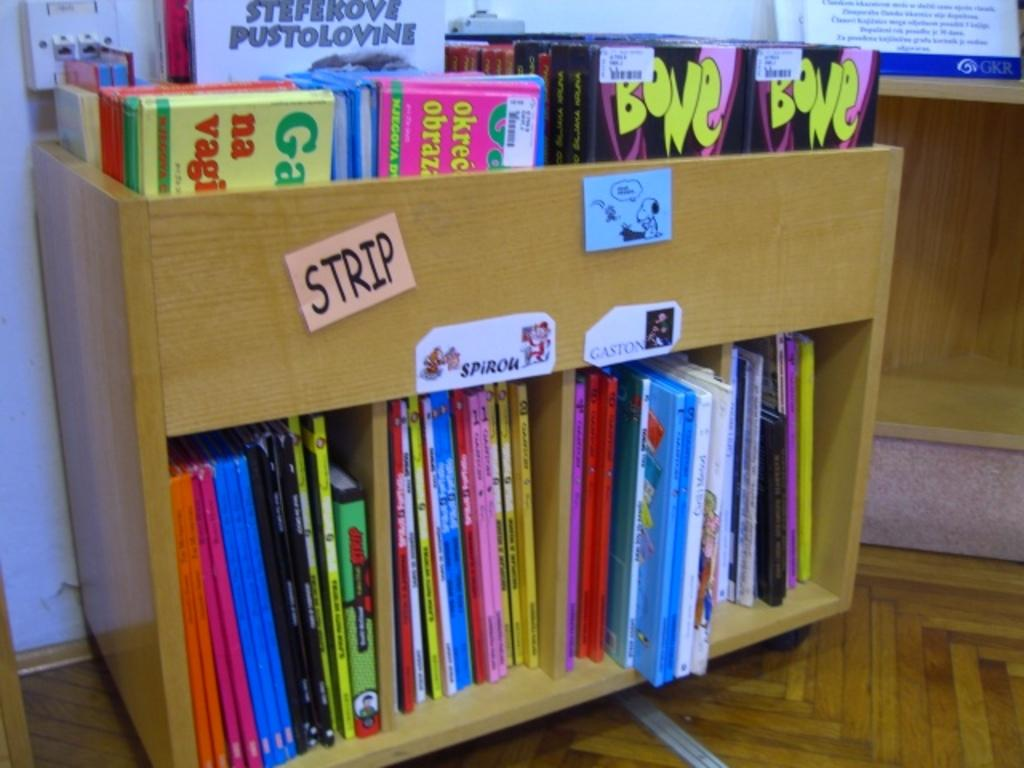<image>
Offer a succinct explanation of the picture presented. The salmon colored tag on the bookcase says strip 